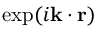Convert formula to latex. <formula><loc_0><loc_0><loc_500><loc_500>\exp ( i k \cdot r )</formula> 